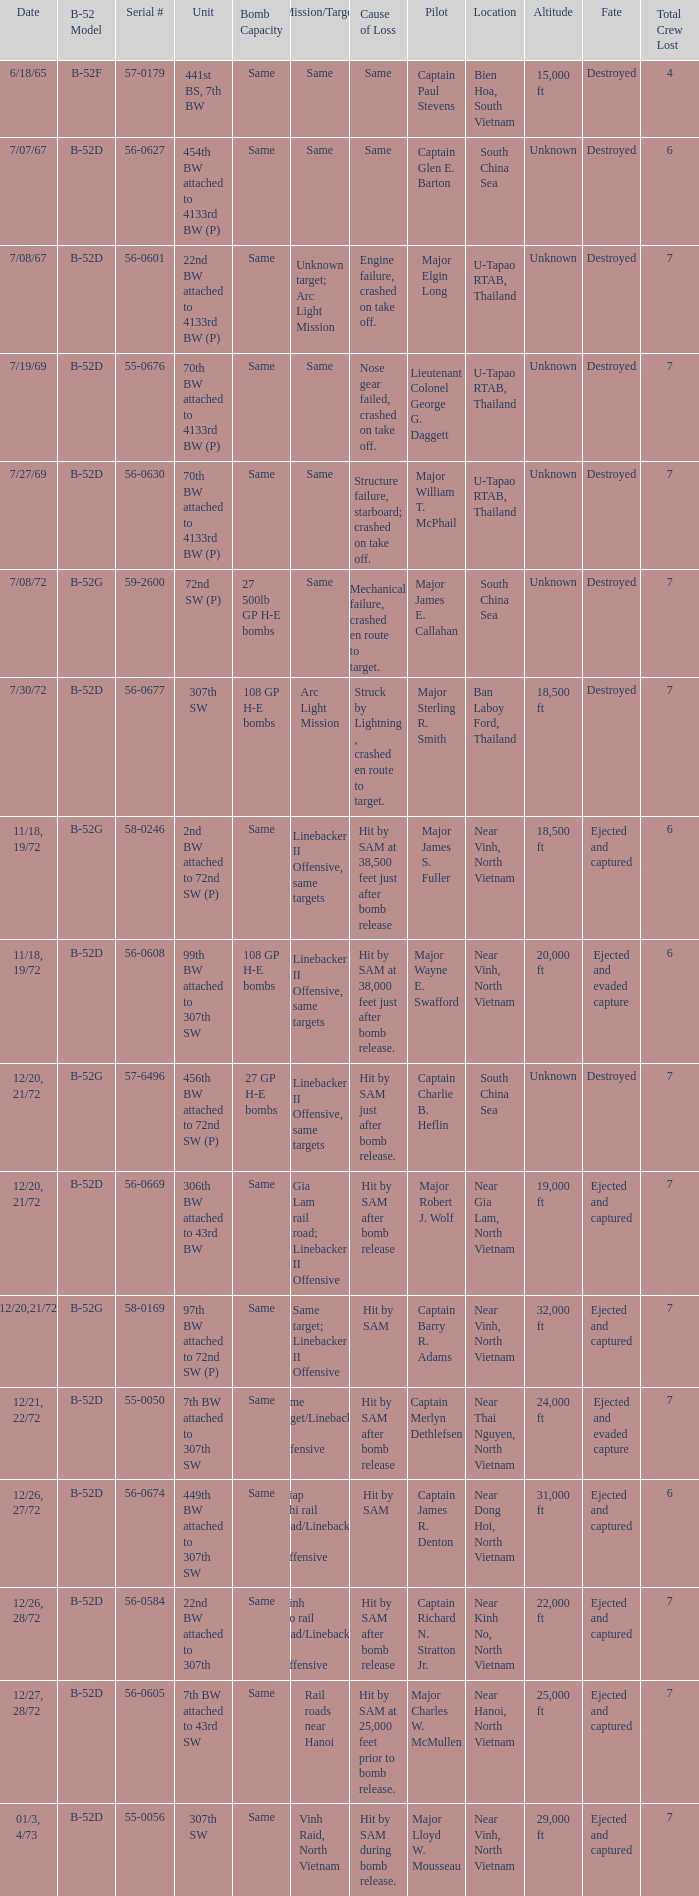When  same target; linebacker ii offensive is the same target what is the unit? 97th BW attached to 72nd SW (P). 